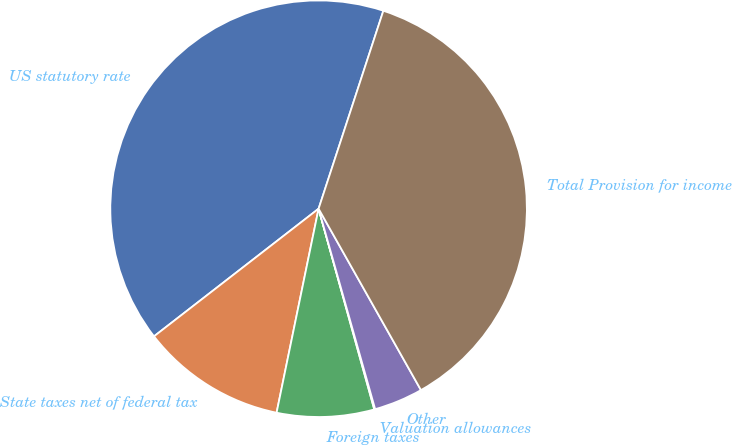<chart> <loc_0><loc_0><loc_500><loc_500><pie_chart><fcel>US statutory rate<fcel>State taxes net of federal tax<fcel>Foreign taxes<fcel>Valuation allowances<fcel>Other<fcel>Total Provision for income<nl><fcel>40.53%<fcel>11.27%<fcel>7.54%<fcel>0.07%<fcel>3.8%<fcel>36.79%<nl></chart> 